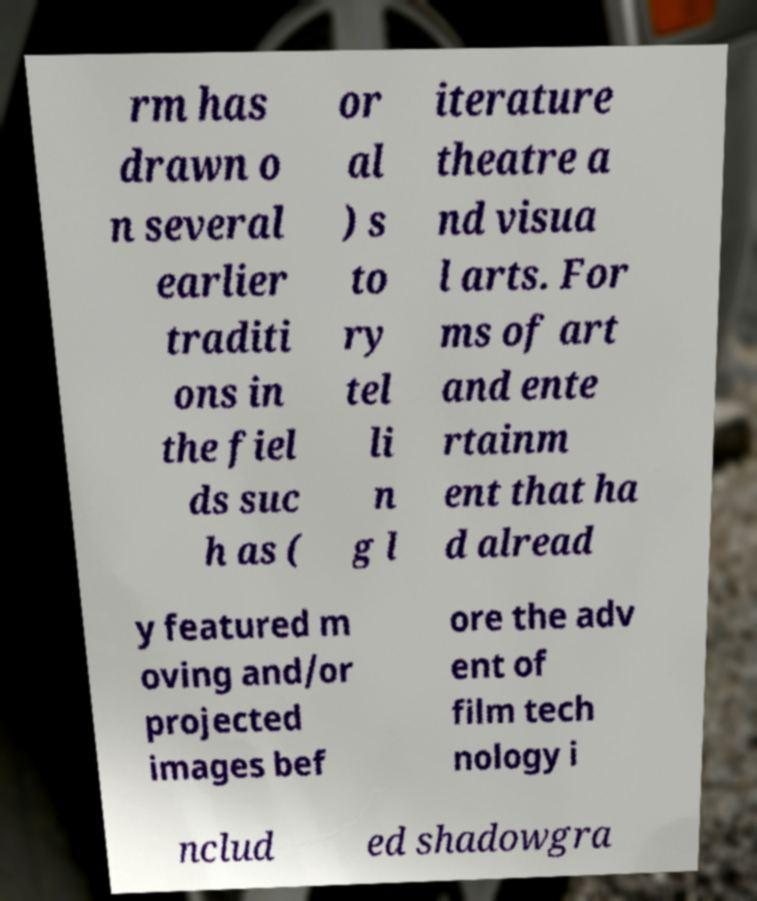For documentation purposes, I need the text within this image transcribed. Could you provide that? rm has drawn o n several earlier traditi ons in the fiel ds suc h as ( or al ) s to ry tel li n g l iterature theatre a nd visua l arts. For ms of art and ente rtainm ent that ha d alread y featured m oving and/or projected images bef ore the adv ent of film tech nology i nclud ed shadowgra 